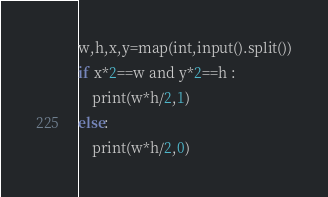<code> <loc_0><loc_0><loc_500><loc_500><_Python_>w,h,x,y=map(int,input().split())
if x*2==w and y*2==h :
    print(w*h/2,1)
else:
    print(w*h/2,0)</code> 